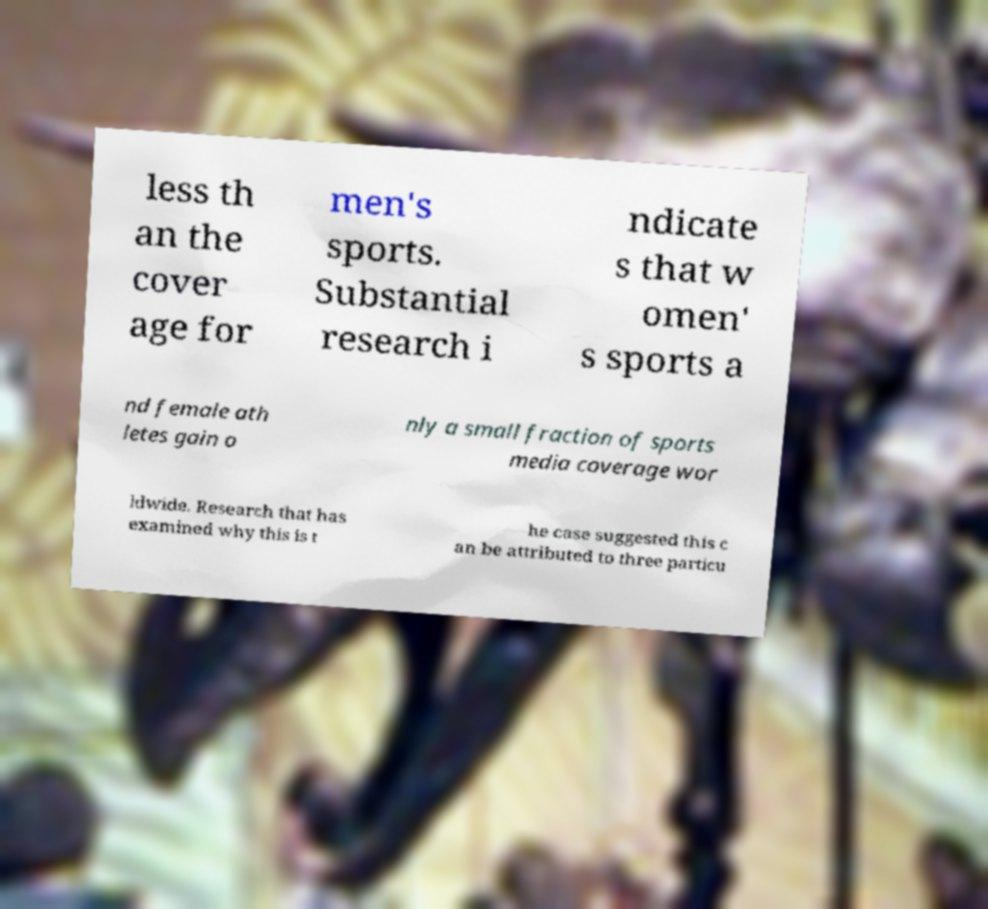Please identify and transcribe the text found in this image. less th an the cover age for men's sports. Substantial research i ndicate s that w omen' s sports a nd female ath letes gain o nly a small fraction of sports media coverage wor ldwide. Research that has examined why this is t he case suggested this c an be attributed to three particu 